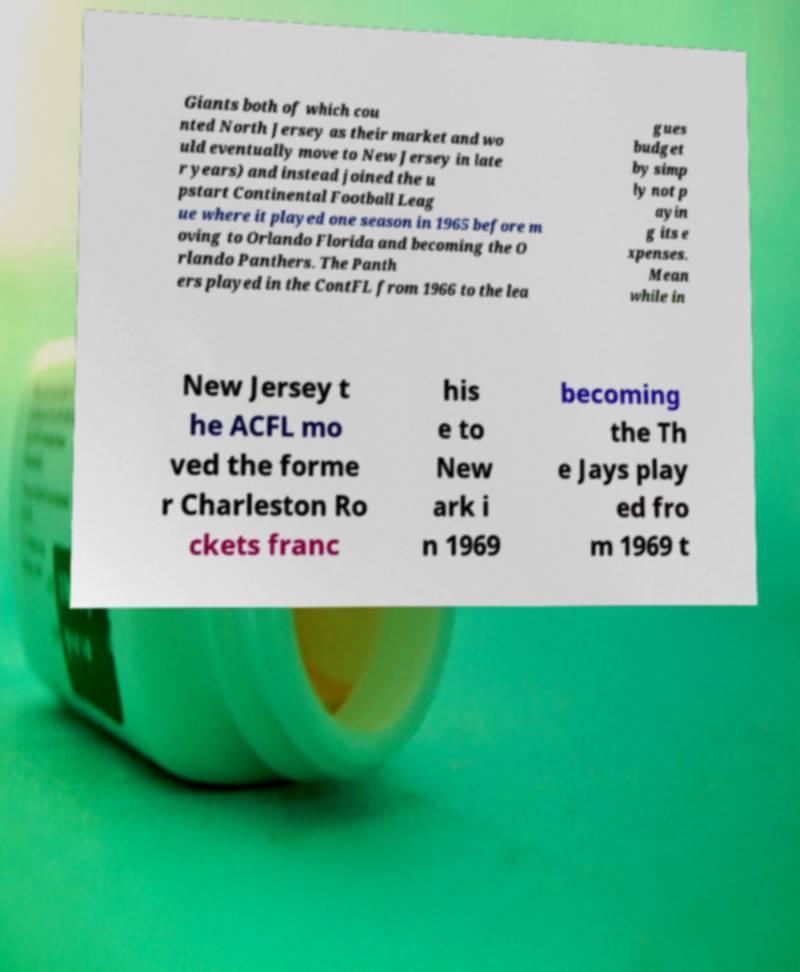Can you accurately transcribe the text from the provided image for me? Giants both of which cou nted North Jersey as their market and wo uld eventually move to New Jersey in late r years) and instead joined the u pstart Continental Football Leag ue where it played one season in 1965 before m oving to Orlando Florida and becoming the O rlando Panthers. The Panth ers played in the ContFL from 1966 to the lea gues budget by simp ly not p ayin g its e xpenses. Mean while in New Jersey t he ACFL mo ved the forme r Charleston Ro ckets franc his e to New ark i n 1969 becoming the Th e Jays play ed fro m 1969 t 